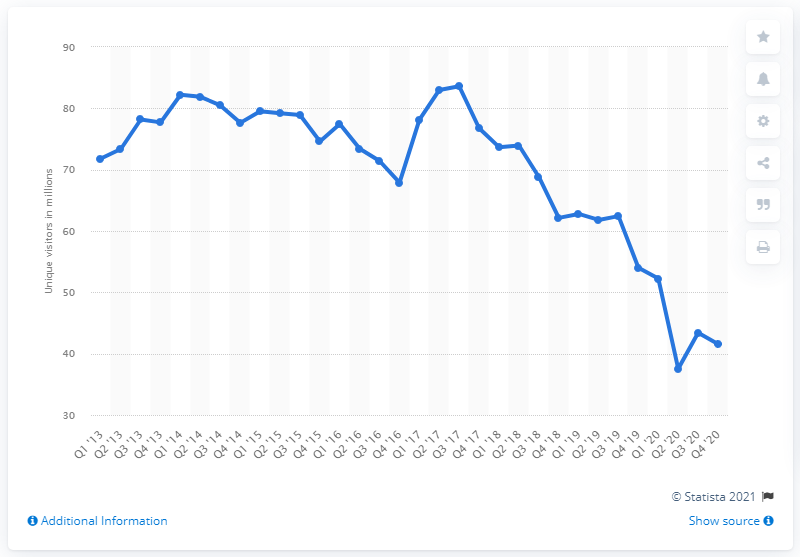Outline some significant characteristics in this image. Approximately 62.43 monthly users had Yelp two years prior. As of the most recent reported period, Yelp had 41,560 unique visitors. 